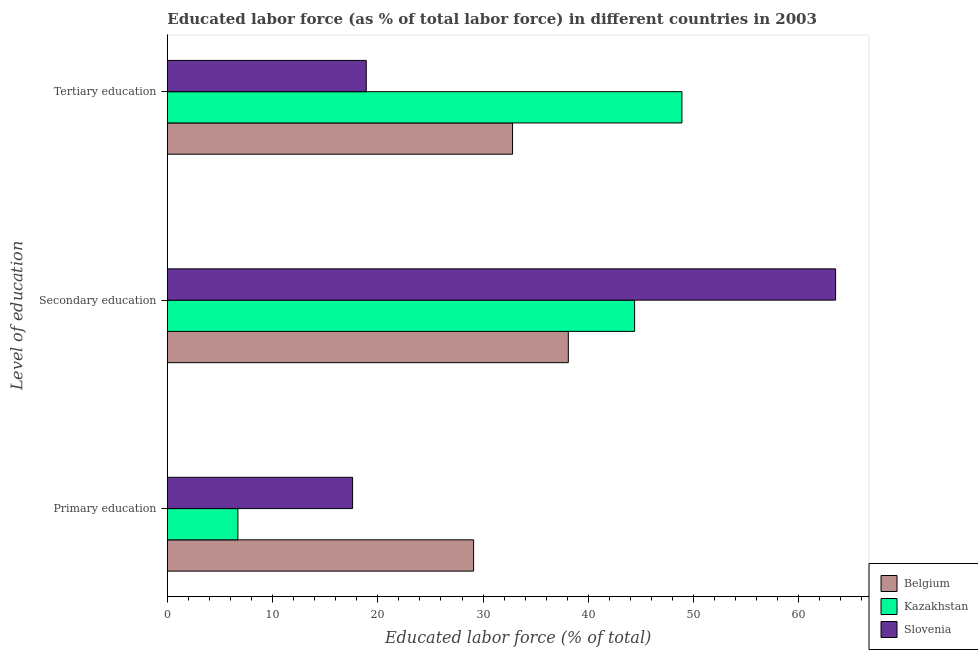How many different coloured bars are there?
Provide a succinct answer. 3. How many groups of bars are there?
Give a very brief answer. 3. Are the number of bars on each tick of the Y-axis equal?
Your answer should be very brief. Yes. How many bars are there on the 1st tick from the top?
Keep it short and to the point. 3. What is the label of the 1st group of bars from the top?
Make the answer very short. Tertiary education. What is the percentage of labor force who received tertiary education in Belgium?
Offer a terse response. 32.8. Across all countries, what is the maximum percentage of labor force who received primary education?
Offer a terse response. 29.1. Across all countries, what is the minimum percentage of labor force who received secondary education?
Provide a short and direct response. 38.1. In which country was the percentage of labor force who received primary education maximum?
Your response must be concise. Belgium. In which country was the percentage of labor force who received primary education minimum?
Make the answer very short. Kazakhstan. What is the total percentage of labor force who received primary education in the graph?
Your answer should be very brief. 53.4. What is the difference between the percentage of labor force who received primary education in Belgium and that in Kazakhstan?
Provide a short and direct response. 22.4. What is the difference between the percentage of labor force who received primary education in Slovenia and the percentage of labor force who received secondary education in Belgium?
Offer a very short reply. -20.5. What is the average percentage of labor force who received tertiary education per country?
Give a very brief answer. 33.53. What is the difference between the percentage of labor force who received secondary education and percentage of labor force who received primary education in Belgium?
Your answer should be very brief. 9. In how many countries, is the percentage of labor force who received secondary education greater than 16 %?
Your answer should be compact. 3. What is the ratio of the percentage of labor force who received primary education in Slovenia to that in Kazakhstan?
Offer a terse response. 2.63. Is the percentage of labor force who received tertiary education in Slovenia less than that in Belgium?
Your response must be concise. Yes. Is the difference between the percentage of labor force who received primary education in Slovenia and Kazakhstan greater than the difference between the percentage of labor force who received tertiary education in Slovenia and Kazakhstan?
Your response must be concise. Yes. What is the difference between the highest and the second highest percentage of labor force who received tertiary education?
Offer a very short reply. 16.1. What is the difference between the highest and the lowest percentage of labor force who received tertiary education?
Offer a very short reply. 30. What does the 2nd bar from the top in Tertiary education represents?
Ensure brevity in your answer.  Kazakhstan. What does the 3rd bar from the bottom in Secondary education represents?
Keep it short and to the point. Slovenia. Is it the case that in every country, the sum of the percentage of labor force who received primary education and percentage of labor force who received secondary education is greater than the percentage of labor force who received tertiary education?
Provide a short and direct response. Yes. How many legend labels are there?
Give a very brief answer. 3. What is the title of the graph?
Give a very brief answer. Educated labor force (as % of total labor force) in different countries in 2003. Does "Vietnam" appear as one of the legend labels in the graph?
Your answer should be very brief. No. What is the label or title of the X-axis?
Offer a terse response. Educated labor force (% of total). What is the label or title of the Y-axis?
Your answer should be very brief. Level of education. What is the Educated labor force (% of total) in Belgium in Primary education?
Your answer should be very brief. 29.1. What is the Educated labor force (% of total) in Kazakhstan in Primary education?
Offer a very short reply. 6.7. What is the Educated labor force (% of total) of Slovenia in Primary education?
Your response must be concise. 17.6. What is the Educated labor force (% of total) of Belgium in Secondary education?
Make the answer very short. 38.1. What is the Educated labor force (% of total) of Kazakhstan in Secondary education?
Provide a short and direct response. 44.4. What is the Educated labor force (% of total) of Slovenia in Secondary education?
Offer a terse response. 63.5. What is the Educated labor force (% of total) of Belgium in Tertiary education?
Offer a terse response. 32.8. What is the Educated labor force (% of total) in Kazakhstan in Tertiary education?
Your answer should be compact. 48.9. What is the Educated labor force (% of total) of Slovenia in Tertiary education?
Your answer should be very brief. 18.9. Across all Level of education, what is the maximum Educated labor force (% of total) of Belgium?
Your answer should be very brief. 38.1. Across all Level of education, what is the maximum Educated labor force (% of total) in Kazakhstan?
Your answer should be very brief. 48.9. Across all Level of education, what is the maximum Educated labor force (% of total) of Slovenia?
Provide a short and direct response. 63.5. Across all Level of education, what is the minimum Educated labor force (% of total) in Belgium?
Provide a short and direct response. 29.1. Across all Level of education, what is the minimum Educated labor force (% of total) of Kazakhstan?
Offer a very short reply. 6.7. Across all Level of education, what is the minimum Educated labor force (% of total) in Slovenia?
Offer a terse response. 17.6. What is the total Educated labor force (% of total) of Kazakhstan in the graph?
Your response must be concise. 100. What is the total Educated labor force (% of total) of Slovenia in the graph?
Give a very brief answer. 100. What is the difference between the Educated labor force (% of total) of Belgium in Primary education and that in Secondary education?
Your answer should be very brief. -9. What is the difference between the Educated labor force (% of total) of Kazakhstan in Primary education and that in Secondary education?
Make the answer very short. -37.7. What is the difference between the Educated labor force (% of total) of Slovenia in Primary education and that in Secondary education?
Keep it short and to the point. -45.9. What is the difference between the Educated labor force (% of total) in Belgium in Primary education and that in Tertiary education?
Give a very brief answer. -3.7. What is the difference between the Educated labor force (% of total) of Kazakhstan in Primary education and that in Tertiary education?
Offer a very short reply. -42.2. What is the difference between the Educated labor force (% of total) in Slovenia in Primary education and that in Tertiary education?
Keep it short and to the point. -1.3. What is the difference between the Educated labor force (% of total) of Kazakhstan in Secondary education and that in Tertiary education?
Provide a short and direct response. -4.5. What is the difference between the Educated labor force (% of total) of Slovenia in Secondary education and that in Tertiary education?
Provide a succinct answer. 44.6. What is the difference between the Educated labor force (% of total) of Belgium in Primary education and the Educated labor force (% of total) of Kazakhstan in Secondary education?
Give a very brief answer. -15.3. What is the difference between the Educated labor force (% of total) of Belgium in Primary education and the Educated labor force (% of total) of Slovenia in Secondary education?
Offer a very short reply. -34.4. What is the difference between the Educated labor force (% of total) of Kazakhstan in Primary education and the Educated labor force (% of total) of Slovenia in Secondary education?
Keep it short and to the point. -56.8. What is the difference between the Educated labor force (% of total) of Belgium in Primary education and the Educated labor force (% of total) of Kazakhstan in Tertiary education?
Your answer should be very brief. -19.8. What is the difference between the Educated labor force (% of total) of Belgium in Primary education and the Educated labor force (% of total) of Slovenia in Tertiary education?
Your answer should be very brief. 10.2. What is the difference between the Educated labor force (% of total) in Kazakhstan in Primary education and the Educated labor force (% of total) in Slovenia in Tertiary education?
Ensure brevity in your answer.  -12.2. What is the difference between the Educated labor force (% of total) of Kazakhstan in Secondary education and the Educated labor force (% of total) of Slovenia in Tertiary education?
Offer a very short reply. 25.5. What is the average Educated labor force (% of total) in Belgium per Level of education?
Your response must be concise. 33.33. What is the average Educated labor force (% of total) in Kazakhstan per Level of education?
Give a very brief answer. 33.33. What is the average Educated labor force (% of total) in Slovenia per Level of education?
Ensure brevity in your answer.  33.33. What is the difference between the Educated labor force (% of total) of Belgium and Educated labor force (% of total) of Kazakhstan in Primary education?
Ensure brevity in your answer.  22.4. What is the difference between the Educated labor force (% of total) in Kazakhstan and Educated labor force (% of total) in Slovenia in Primary education?
Give a very brief answer. -10.9. What is the difference between the Educated labor force (% of total) of Belgium and Educated labor force (% of total) of Slovenia in Secondary education?
Ensure brevity in your answer.  -25.4. What is the difference between the Educated labor force (% of total) in Kazakhstan and Educated labor force (% of total) in Slovenia in Secondary education?
Keep it short and to the point. -19.1. What is the difference between the Educated labor force (% of total) in Belgium and Educated labor force (% of total) in Kazakhstan in Tertiary education?
Ensure brevity in your answer.  -16.1. What is the difference between the Educated labor force (% of total) of Belgium and Educated labor force (% of total) of Slovenia in Tertiary education?
Your answer should be very brief. 13.9. What is the ratio of the Educated labor force (% of total) in Belgium in Primary education to that in Secondary education?
Offer a very short reply. 0.76. What is the ratio of the Educated labor force (% of total) of Kazakhstan in Primary education to that in Secondary education?
Your answer should be compact. 0.15. What is the ratio of the Educated labor force (% of total) of Slovenia in Primary education to that in Secondary education?
Your answer should be very brief. 0.28. What is the ratio of the Educated labor force (% of total) of Belgium in Primary education to that in Tertiary education?
Keep it short and to the point. 0.89. What is the ratio of the Educated labor force (% of total) in Kazakhstan in Primary education to that in Tertiary education?
Your answer should be compact. 0.14. What is the ratio of the Educated labor force (% of total) of Slovenia in Primary education to that in Tertiary education?
Provide a short and direct response. 0.93. What is the ratio of the Educated labor force (% of total) in Belgium in Secondary education to that in Tertiary education?
Offer a terse response. 1.16. What is the ratio of the Educated labor force (% of total) in Kazakhstan in Secondary education to that in Tertiary education?
Your answer should be very brief. 0.91. What is the ratio of the Educated labor force (% of total) in Slovenia in Secondary education to that in Tertiary education?
Ensure brevity in your answer.  3.36. What is the difference between the highest and the second highest Educated labor force (% of total) of Kazakhstan?
Your answer should be compact. 4.5. What is the difference between the highest and the second highest Educated labor force (% of total) in Slovenia?
Ensure brevity in your answer.  44.6. What is the difference between the highest and the lowest Educated labor force (% of total) of Belgium?
Give a very brief answer. 9. What is the difference between the highest and the lowest Educated labor force (% of total) of Kazakhstan?
Ensure brevity in your answer.  42.2. What is the difference between the highest and the lowest Educated labor force (% of total) in Slovenia?
Your answer should be very brief. 45.9. 